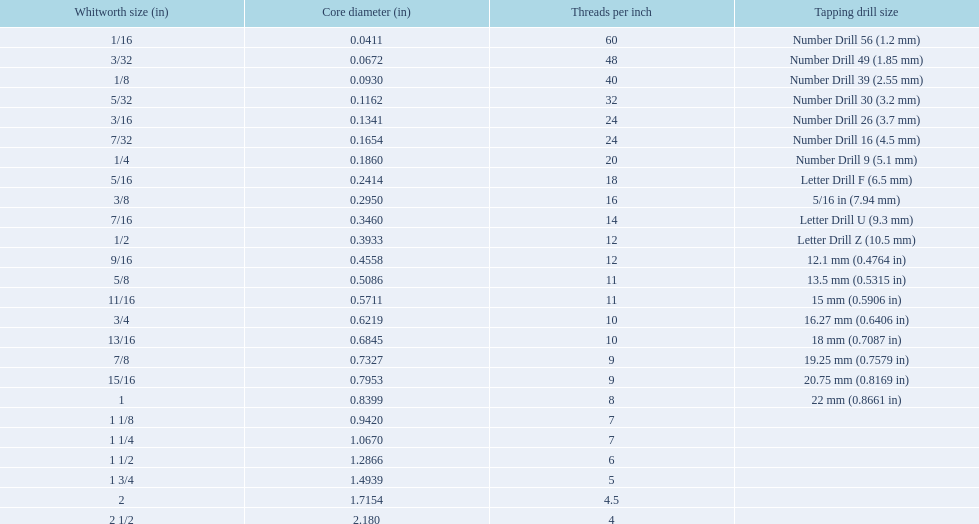What are the sizes of threads per inch? 60, 48, 40, 32, 24, 24, 20, 18, 16, 14, 12, 12, 11, 11, 10, 10, 9, 9, 8, 7, 7, 6, 5, 4.5, 4. Which whitworth size has only 5 threads per inch? 1 3/4. 